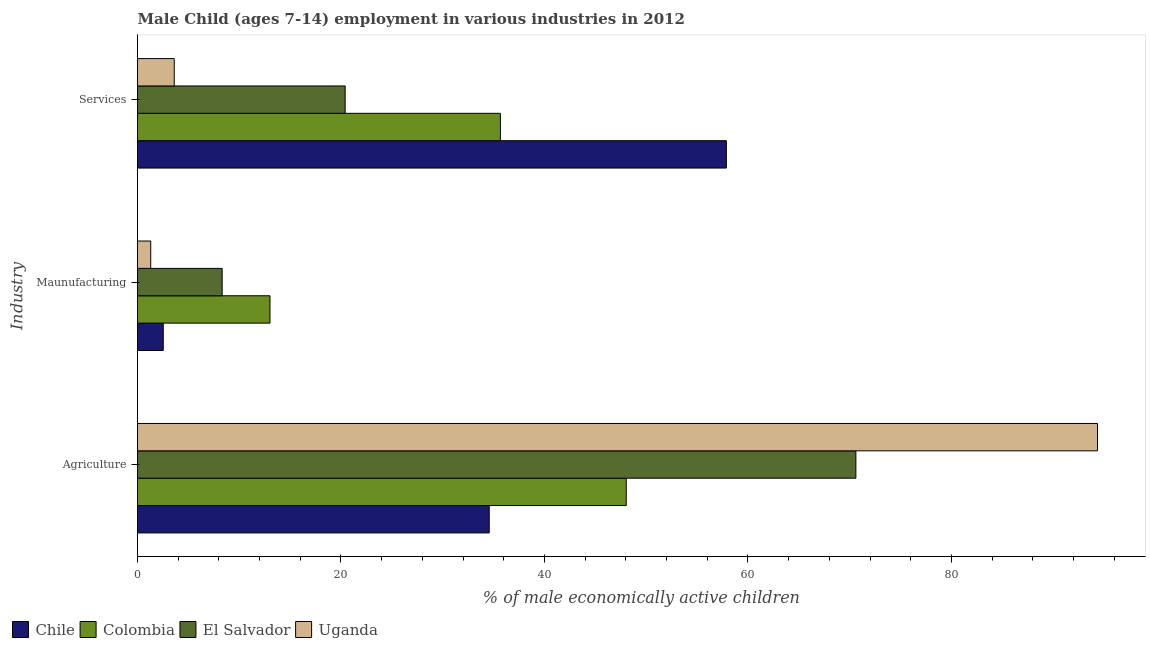Are the number of bars per tick equal to the number of legend labels?
Offer a very short reply. Yes. Are the number of bars on each tick of the Y-axis equal?
Offer a very short reply. Yes. How many bars are there on the 3rd tick from the top?
Your response must be concise. 4. What is the label of the 3rd group of bars from the top?
Give a very brief answer. Agriculture. What is the percentage of economically active children in manufacturing in Uganda?
Keep it short and to the point. 1.3. Across all countries, what is the maximum percentage of economically active children in manufacturing?
Give a very brief answer. 13.02. Across all countries, what is the minimum percentage of economically active children in agriculture?
Offer a very short reply. 34.57. In which country was the percentage of economically active children in agriculture maximum?
Ensure brevity in your answer.  Uganda. In which country was the percentage of economically active children in services minimum?
Keep it short and to the point. Uganda. What is the total percentage of economically active children in services in the graph?
Make the answer very short. 117.57. What is the difference between the percentage of economically active children in services in El Salvador and that in Uganda?
Keep it short and to the point. 16.8. What is the difference between the percentage of economically active children in manufacturing in Uganda and the percentage of economically active children in agriculture in Chile?
Offer a very short reply. -33.27. What is the average percentage of economically active children in agriculture per country?
Your answer should be very brief. 61.89. What is the difference between the percentage of economically active children in services and percentage of economically active children in agriculture in Chile?
Your answer should be very brief. 23.31. What is the ratio of the percentage of economically active children in services in Uganda to that in El Salvador?
Keep it short and to the point. 0.18. What is the difference between the highest and the second highest percentage of economically active children in services?
Keep it short and to the point. 22.21. What is the difference between the highest and the lowest percentage of economically active children in manufacturing?
Provide a succinct answer. 11.72. Is the sum of the percentage of economically active children in agriculture in Colombia and El Salvador greater than the maximum percentage of economically active children in manufacturing across all countries?
Keep it short and to the point. Yes. What does the 3rd bar from the top in Services represents?
Provide a short and direct response. Colombia. What does the 4th bar from the bottom in Agriculture represents?
Offer a terse response. Uganda. Is it the case that in every country, the sum of the percentage of economically active children in agriculture and percentage of economically active children in manufacturing is greater than the percentage of economically active children in services?
Offer a terse response. No. Are all the bars in the graph horizontal?
Give a very brief answer. Yes. How many countries are there in the graph?
Provide a short and direct response. 4. Are the values on the major ticks of X-axis written in scientific E-notation?
Offer a very short reply. No. Does the graph contain grids?
Keep it short and to the point. No. What is the title of the graph?
Make the answer very short. Male Child (ages 7-14) employment in various industries in 2012. What is the label or title of the X-axis?
Ensure brevity in your answer.  % of male economically active children. What is the label or title of the Y-axis?
Ensure brevity in your answer.  Industry. What is the % of male economically active children in Chile in Agriculture?
Offer a terse response. 34.57. What is the % of male economically active children of Colombia in Agriculture?
Your answer should be very brief. 48.04. What is the % of male economically active children in El Salvador in Agriculture?
Offer a terse response. 70.61. What is the % of male economically active children of Uganda in Agriculture?
Give a very brief answer. 94.36. What is the % of male economically active children in Chile in Maunufacturing?
Provide a short and direct response. 2.53. What is the % of male economically active children in Colombia in Maunufacturing?
Give a very brief answer. 13.02. What is the % of male economically active children in El Salvador in Maunufacturing?
Your response must be concise. 8.32. What is the % of male economically active children in Chile in Services?
Your response must be concise. 57.88. What is the % of male economically active children of Colombia in Services?
Ensure brevity in your answer.  35.67. What is the % of male economically active children in El Salvador in Services?
Your response must be concise. 20.41. What is the % of male economically active children in Uganda in Services?
Give a very brief answer. 3.61. Across all Industry, what is the maximum % of male economically active children in Chile?
Make the answer very short. 57.88. Across all Industry, what is the maximum % of male economically active children of Colombia?
Keep it short and to the point. 48.04. Across all Industry, what is the maximum % of male economically active children of El Salvador?
Your response must be concise. 70.61. Across all Industry, what is the maximum % of male economically active children of Uganda?
Keep it short and to the point. 94.36. Across all Industry, what is the minimum % of male economically active children in Chile?
Provide a succinct answer. 2.53. Across all Industry, what is the minimum % of male economically active children in Colombia?
Your answer should be very brief. 13.02. Across all Industry, what is the minimum % of male economically active children in El Salvador?
Give a very brief answer. 8.32. What is the total % of male economically active children of Chile in the graph?
Your answer should be very brief. 94.98. What is the total % of male economically active children of Colombia in the graph?
Keep it short and to the point. 96.73. What is the total % of male economically active children in El Salvador in the graph?
Provide a succinct answer. 99.34. What is the total % of male economically active children of Uganda in the graph?
Offer a very short reply. 99.27. What is the difference between the % of male economically active children in Chile in Agriculture and that in Maunufacturing?
Offer a very short reply. 32.04. What is the difference between the % of male economically active children of Colombia in Agriculture and that in Maunufacturing?
Make the answer very short. 35.02. What is the difference between the % of male economically active children in El Salvador in Agriculture and that in Maunufacturing?
Give a very brief answer. 62.29. What is the difference between the % of male economically active children in Uganda in Agriculture and that in Maunufacturing?
Keep it short and to the point. 93.06. What is the difference between the % of male economically active children in Chile in Agriculture and that in Services?
Give a very brief answer. -23.31. What is the difference between the % of male economically active children of Colombia in Agriculture and that in Services?
Keep it short and to the point. 12.37. What is the difference between the % of male economically active children in El Salvador in Agriculture and that in Services?
Provide a short and direct response. 50.2. What is the difference between the % of male economically active children in Uganda in Agriculture and that in Services?
Keep it short and to the point. 90.75. What is the difference between the % of male economically active children in Chile in Maunufacturing and that in Services?
Provide a succinct answer. -55.35. What is the difference between the % of male economically active children in Colombia in Maunufacturing and that in Services?
Give a very brief answer. -22.65. What is the difference between the % of male economically active children of El Salvador in Maunufacturing and that in Services?
Your answer should be compact. -12.09. What is the difference between the % of male economically active children of Uganda in Maunufacturing and that in Services?
Give a very brief answer. -2.31. What is the difference between the % of male economically active children of Chile in Agriculture and the % of male economically active children of Colombia in Maunufacturing?
Offer a terse response. 21.55. What is the difference between the % of male economically active children of Chile in Agriculture and the % of male economically active children of El Salvador in Maunufacturing?
Your answer should be very brief. 26.25. What is the difference between the % of male economically active children in Chile in Agriculture and the % of male economically active children in Uganda in Maunufacturing?
Your response must be concise. 33.27. What is the difference between the % of male economically active children in Colombia in Agriculture and the % of male economically active children in El Salvador in Maunufacturing?
Keep it short and to the point. 39.72. What is the difference between the % of male economically active children of Colombia in Agriculture and the % of male economically active children of Uganda in Maunufacturing?
Keep it short and to the point. 46.74. What is the difference between the % of male economically active children in El Salvador in Agriculture and the % of male economically active children in Uganda in Maunufacturing?
Offer a terse response. 69.31. What is the difference between the % of male economically active children of Chile in Agriculture and the % of male economically active children of Colombia in Services?
Ensure brevity in your answer.  -1.1. What is the difference between the % of male economically active children in Chile in Agriculture and the % of male economically active children in El Salvador in Services?
Provide a succinct answer. 14.16. What is the difference between the % of male economically active children of Chile in Agriculture and the % of male economically active children of Uganda in Services?
Ensure brevity in your answer.  30.96. What is the difference between the % of male economically active children in Colombia in Agriculture and the % of male economically active children in El Salvador in Services?
Make the answer very short. 27.63. What is the difference between the % of male economically active children in Colombia in Agriculture and the % of male economically active children in Uganda in Services?
Your response must be concise. 44.43. What is the difference between the % of male economically active children in El Salvador in Agriculture and the % of male economically active children in Uganda in Services?
Provide a succinct answer. 67. What is the difference between the % of male economically active children in Chile in Maunufacturing and the % of male economically active children in Colombia in Services?
Your response must be concise. -33.14. What is the difference between the % of male economically active children in Chile in Maunufacturing and the % of male economically active children in El Salvador in Services?
Offer a terse response. -17.88. What is the difference between the % of male economically active children in Chile in Maunufacturing and the % of male economically active children in Uganda in Services?
Provide a short and direct response. -1.08. What is the difference between the % of male economically active children of Colombia in Maunufacturing and the % of male economically active children of El Salvador in Services?
Your answer should be very brief. -7.39. What is the difference between the % of male economically active children in Colombia in Maunufacturing and the % of male economically active children in Uganda in Services?
Your answer should be very brief. 9.41. What is the difference between the % of male economically active children of El Salvador in Maunufacturing and the % of male economically active children of Uganda in Services?
Keep it short and to the point. 4.71. What is the average % of male economically active children in Chile per Industry?
Ensure brevity in your answer.  31.66. What is the average % of male economically active children in Colombia per Industry?
Give a very brief answer. 32.24. What is the average % of male economically active children in El Salvador per Industry?
Your answer should be very brief. 33.11. What is the average % of male economically active children in Uganda per Industry?
Provide a succinct answer. 33.09. What is the difference between the % of male economically active children in Chile and % of male economically active children in Colombia in Agriculture?
Offer a very short reply. -13.47. What is the difference between the % of male economically active children in Chile and % of male economically active children in El Salvador in Agriculture?
Your answer should be compact. -36.04. What is the difference between the % of male economically active children of Chile and % of male economically active children of Uganda in Agriculture?
Give a very brief answer. -59.79. What is the difference between the % of male economically active children of Colombia and % of male economically active children of El Salvador in Agriculture?
Offer a terse response. -22.57. What is the difference between the % of male economically active children in Colombia and % of male economically active children in Uganda in Agriculture?
Give a very brief answer. -46.32. What is the difference between the % of male economically active children in El Salvador and % of male economically active children in Uganda in Agriculture?
Your answer should be compact. -23.75. What is the difference between the % of male economically active children of Chile and % of male economically active children of Colombia in Maunufacturing?
Offer a terse response. -10.49. What is the difference between the % of male economically active children of Chile and % of male economically active children of El Salvador in Maunufacturing?
Offer a terse response. -5.79. What is the difference between the % of male economically active children of Chile and % of male economically active children of Uganda in Maunufacturing?
Offer a very short reply. 1.23. What is the difference between the % of male economically active children in Colombia and % of male economically active children in El Salvador in Maunufacturing?
Give a very brief answer. 4.7. What is the difference between the % of male economically active children of Colombia and % of male economically active children of Uganda in Maunufacturing?
Make the answer very short. 11.72. What is the difference between the % of male economically active children in El Salvador and % of male economically active children in Uganda in Maunufacturing?
Give a very brief answer. 7.02. What is the difference between the % of male economically active children of Chile and % of male economically active children of Colombia in Services?
Provide a short and direct response. 22.21. What is the difference between the % of male economically active children of Chile and % of male economically active children of El Salvador in Services?
Your response must be concise. 37.47. What is the difference between the % of male economically active children of Chile and % of male economically active children of Uganda in Services?
Your answer should be compact. 54.27. What is the difference between the % of male economically active children in Colombia and % of male economically active children in El Salvador in Services?
Your answer should be very brief. 15.26. What is the difference between the % of male economically active children in Colombia and % of male economically active children in Uganda in Services?
Offer a very short reply. 32.06. What is the ratio of the % of male economically active children of Chile in Agriculture to that in Maunufacturing?
Make the answer very short. 13.66. What is the ratio of the % of male economically active children in Colombia in Agriculture to that in Maunufacturing?
Provide a short and direct response. 3.69. What is the ratio of the % of male economically active children of El Salvador in Agriculture to that in Maunufacturing?
Your answer should be very brief. 8.49. What is the ratio of the % of male economically active children in Uganda in Agriculture to that in Maunufacturing?
Give a very brief answer. 72.58. What is the ratio of the % of male economically active children of Chile in Agriculture to that in Services?
Offer a terse response. 0.6. What is the ratio of the % of male economically active children in Colombia in Agriculture to that in Services?
Your answer should be compact. 1.35. What is the ratio of the % of male economically active children in El Salvador in Agriculture to that in Services?
Make the answer very short. 3.46. What is the ratio of the % of male economically active children of Uganda in Agriculture to that in Services?
Ensure brevity in your answer.  26.14. What is the ratio of the % of male economically active children in Chile in Maunufacturing to that in Services?
Your response must be concise. 0.04. What is the ratio of the % of male economically active children of Colombia in Maunufacturing to that in Services?
Give a very brief answer. 0.36. What is the ratio of the % of male economically active children in El Salvador in Maunufacturing to that in Services?
Keep it short and to the point. 0.41. What is the ratio of the % of male economically active children of Uganda in Maunufacturing to that in Services?
Give a very brief answer. 0.36. What is the difference between the highest and the second highest % of male economically active children of Chile?
Make the answer very short. 23.31. What is the difference between the highest and the second highest % of male economically active children of Colombia?
Offer a terse response. 12.37. What is the difference between the highest and the second highest % of male economically active children of El Salvador?
Ensure brevity in your answer.  50.2. What is the difference between the highest and the second highest % of male economically active children of Uganda?
Your answer should be compact. 90.75. What is the difference between the highest and the lowest % of male economically active children in Chile?
Your answer should be compact. 55.35. What is the difference between the highest and the lowest % of male economically active children of Colombia?
Your response must be concise. 35.02. What is the difference between the highest and the lowest % of male economically active children in El Salvador?
Offer a very short reply. 62.29. What is the difference between the highest and the lowest % of male economically active children of Uganda?
Your answer should be compact. 93.06. 